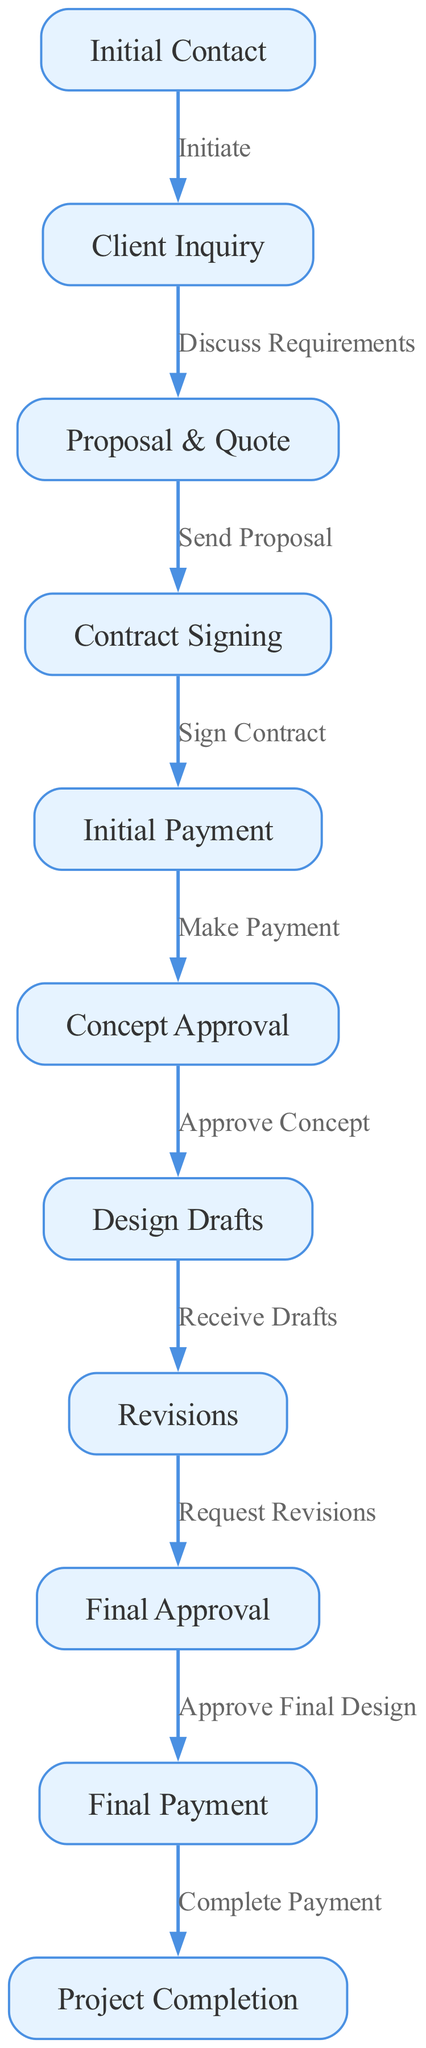What is the first step in the client workflow? The diagram starts with the "Initial Contact" node, which signifies the beginning of the client engagement process.
Answer: Initial Contact How many total nodes are there in the diagram? By counting all the different nodes listed in the diagram, there are a total of 11 nodes representing various stages in the client workflow.
Answer: 11 Which node follows the "Design Drafts" node? After "Design Drafts," the diagram shows an edge leading to the "Revisions" node, indicating that the next step involves receiving and possibly revising the drafts.
Answer: Revisions What is the relationship between "Contract Signing" and "Initial Payment"? The diagram indicates that "Contract Signing" leads to "Initial Payment," meaning that after signing the contract, the next step is to make an initial payment.
Answer: Sign Contract How many edges connect the "Concept Approval" node to subsequent nodes? The "Concept Approval" node connects to one subsequent node, which is "Design Drafts." Thus, there is one outgoing edge from "Concept Approval."
Answer: 1 What is the final step in the client workflow? The diagram concludes with the "Project Completion" node, indicating the ultimate goal of the workflow process after all prior steps are completed.
Answer: Project Completion What payment happens after "Final Approval"? According to the flowchart, the next step after "Final Approval" is "Final Payment," indicating that a final payment is required before project completion.
Answer: Final Payment What does the arrow labeled “Approve Concept” indicate? The arrow from "Concept Approval" to "Design Drafts," labeled "Approve Concept," indicates that once the concept is approved, the process moves on to producing the design drafts.
Answer: Approve Concept Which two nodes are connected directly by the edge labeled "Request Revisions"? The edge labeled "Request Revisions" connects the "Revisions" node to the "Final Approval" node, showing the workflow progression after revisions have been requested.
Answer: Revisions and Final Approval 